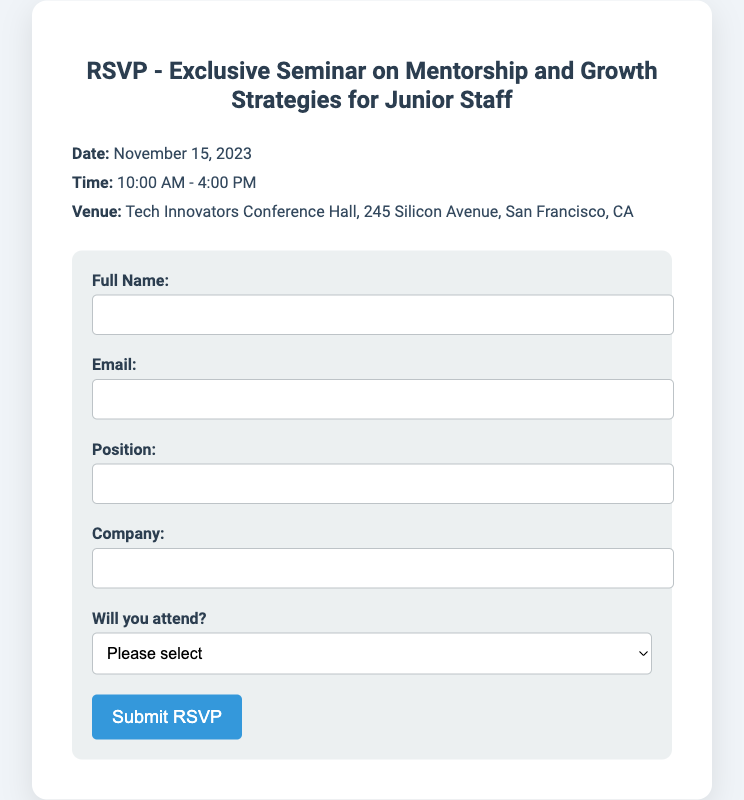What is the date of the seminar? The date of the seminar is mentioned in the event details section of the document.
Answer: November 15, 2023 What time does the seminar start? The starting time of the seminar is provided in the event details section.
Answer: 10:00 AM What is the venue for the seminar? The venue location is specified in the event details section of the document.
Answer: Tech Innovators Conference Hall, 245 Silicon Avenue, San Francisco, CA What information is required in the RSVP form? The RSVP form includes several fields where specific information is required from the attendees, including name, email, position, and company.
Answer: Name, email, position, company What are the possible attendance options in the RSVP form? The attendance options are listed in the RSVP form under the attendance question, specifying whether the person will attend or not.
Answer: Yes, I will attend; No, I cannot attend What is the purpose of this document? The document is specifically designed to gather RSVP information for a seminar focused on mentorship and growth strategies for junior staff.
Answer: RSVP for a seminar How many hours does the seminar last? The duration can be calculated by subtracting the start time from the end time listed in the event details.
Answer: 6 hours What color theme is used in the RSVP card? The color theme can be inferred from the overall design and background colors in the document.
Answer: Blue and white 